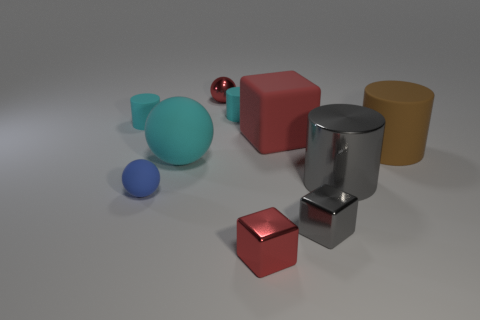Is the color of the shiny ball the same as the block behind the tiny blue matte object?
Ensure brevity in your answer.  Yes. What size is the sphere that is the same color as the matte cube?
Ensure brevity in your answer.  Small. The red thing that is behind the red rubber block has what shape?
Provide a succinct answer. Sphere. Does the tiny shiny block that is on the left side of the large red cube have the same color as the metal ball?
Ensure brevity in your answer.  Yes. What is the material of the small block that is the same color as the metallic sphere?
Your answer should be compact. Metal. There is a gray thing in front of the blue matte thing; does it have the same size as the large sphere?
Provide a succinct answer. No. Are there any large rubber cubes that have the same color as the large sphere?
Provide a succinct answer. No. Are there any gray objects to the right of the cylinder that is in front of the large matte cylinder?
Your answer should be compact. No. Is there a red block made of the same material as the gray cube?
Offer a terse response. Yes. The tiny sphere on the left side of the rubber sphere that is on the right side of the blue matte thing is made of what material?
Make the answer very short. Rubber. 